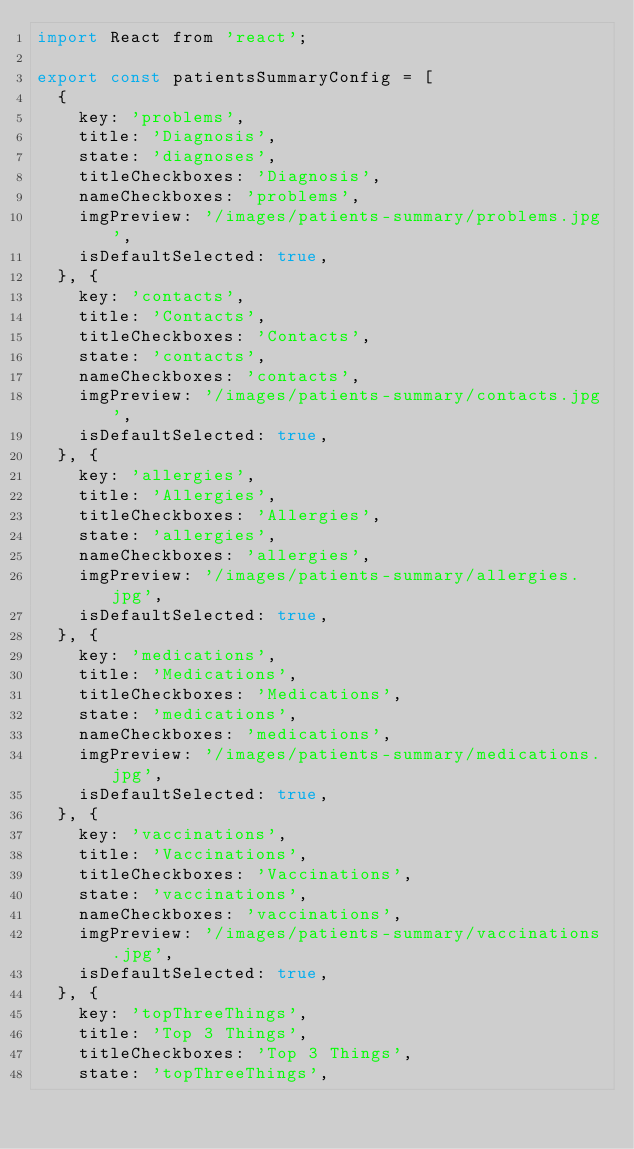<code> <loc_0><loc_0><loc_500><loc_500><_JavaScript_>import React from 'react';

export const patientsSummaryConfig = [
  {
    key: 'problems',
    title: 'Diagnosis',
    state: 'diagnoses',
    titleCheckboxes: 'Diagnosis',
    nameCheckboxes: 'problems',
    imgPreview: '/images/patients-summary/problems.jpg',
    isDefaultSelected: true,
  }, {
    key: 'contacts',
    title: 'Contacts',
    titleCheckboxes: 'Contacts',
    state: 'contacts',
    nameCheckboxes: 'contacts',
    imgPreview: '/images/patients-summary/contacts.jpg',
    isDefaultSelected: true,
  }, {
    key: 'allergies',
    title: 'Allergies',
    titleCheckboxes: 'Allergies',
    state: 'allergies',
    nameCheckboxes: 'allergies',
    imgPreview: '/images/patients-summary/allergies.jpg',
    isDefaultSelected: true,
  }, {
    key: 'medications',
    title: 'Medications',
    titleCheckboxes: 'Medications',
    state: 'medications',
    nameCheckboxes: 'medications',
    imgPreview: '/images/patients-summary/medications.jpg',
    isDefaultSelected: true,
  }, {
    key: 'vaccinations',
    title: 'Vaccinations',
    titleCheckboxes: 'Vaccinations',
    state: 'vaccinations',
    nameCheckboxes: 'vaccinations',
    imgPreview: '/images/patients-summary/vaccinations.jpg',
    isDefaultSelected: true,
  }, {
    key: 'topThreeThings',
    title: 'Top 3 Things',
    titleCheckboxes: 'Top 3 Things',
    state: 'topThreeThings',</code> 